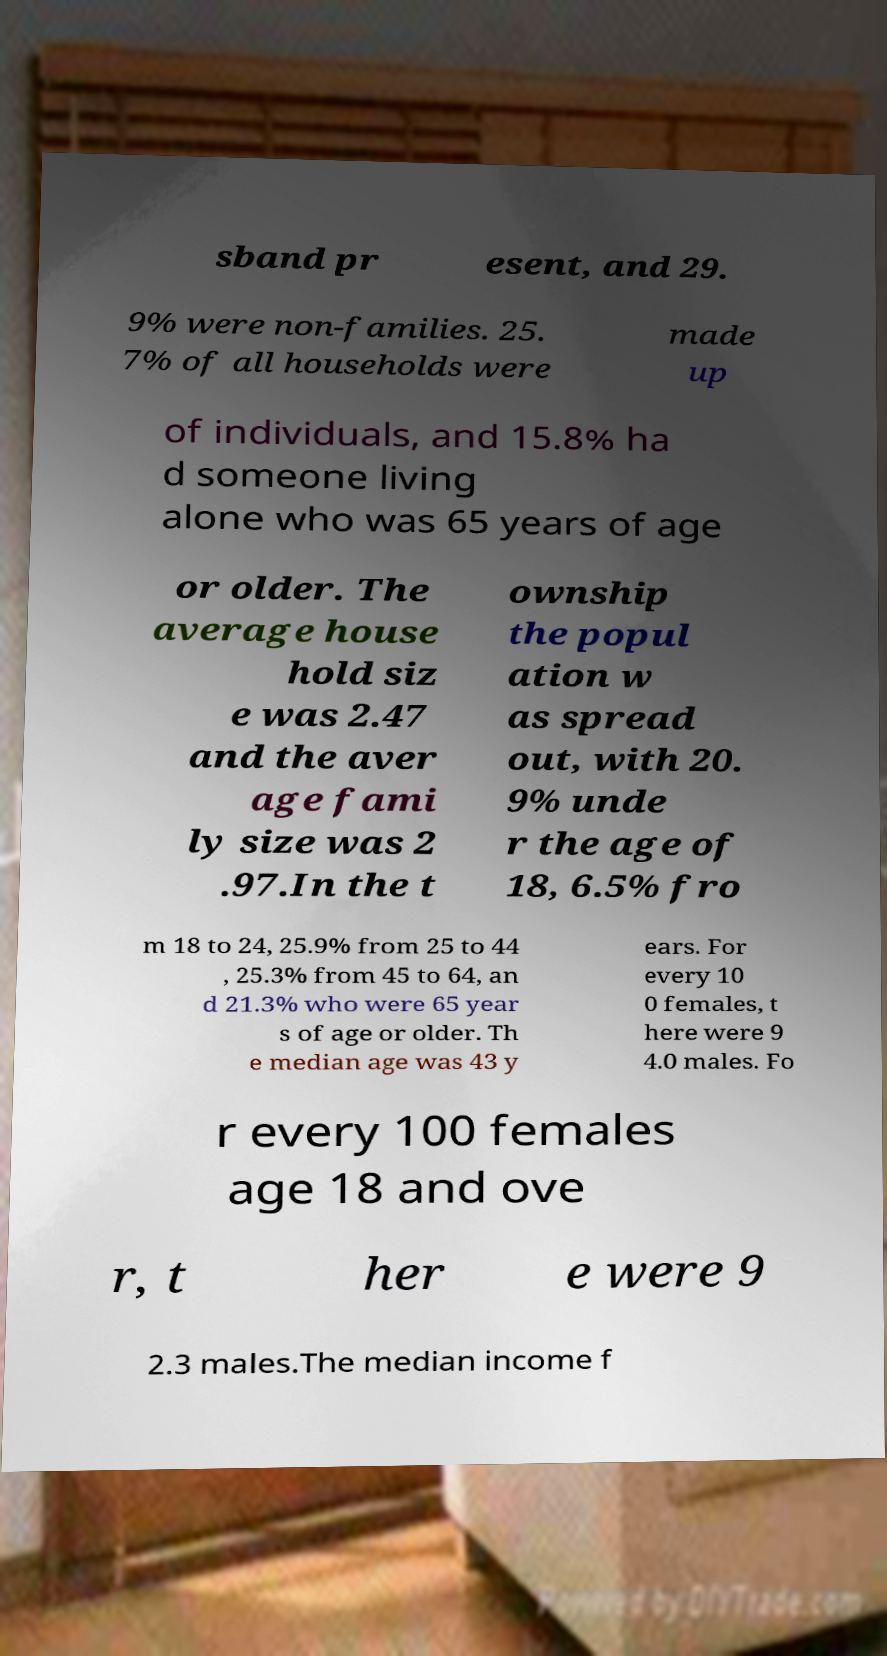Can you read and provide the text displayed in the image?This photo seems to have some interesting text. Can you extract and type it out for me? sband pr esent, and 29. 9% were non-families. 25. 7% of all households were made up of individuals, and 15.8% ha d someone living alone who was 65 years of age or older. The average house hold siz e was 2.47 and the aver age fami ly size was 2 .97.In the t ownship the popul ation w as spread out, with 20. 9% unde r the age of 18, 6.5% fro m 18 to 24, 25.9% from 25 to 44 , 25.3% from 45 to 64, an d 21.3% who were 65 year s of age or older. Th e median age was 43 y ears. For every 10 0 females, t here were 9 4.0 males. Fo r every 100 females age 18 and ove r, t her e were 9 2.3 males.The median income f 